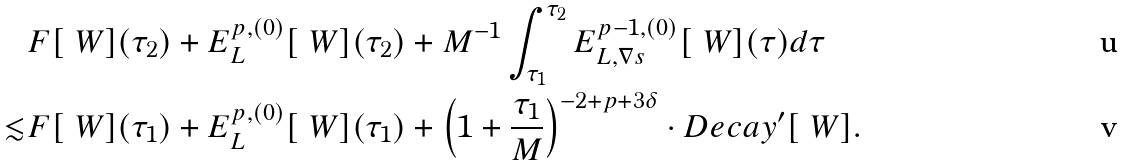Convert formula to latex. <formula><loc_0><loc_0><loc_500><loc_500>& F [ \ W ] ( \tau _ { 2 } ) + E ^ { p , ( 0 ) } _ { L } [ \ W ] ( \tau _ { 2 } ) + M ^ { - 1 } \int _ { \tau _ { 1 } } ^ { \tau _ { 2 } } E ^ { p - 1 , ( 0 ) } _ { L , \nabla s } [ \ W ] ( \tau ) d \tau \\ \lesssim & F [ \ W ] ( \tau _ { 1 } ) + E ^ { p , ( 0 ) } _ { L } [ \ W ] ( \tau _ { 1 } ) + \left ( 1 + \frac { \tau _ { 1 } } { M } \right ) ^ { - 2 + p + 3 \delta } \cdot D e c a y ^ { \prime } [ \ W ] .</formula> 